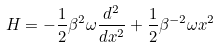<formula> <loc_0><loc_0><loc_500><loc_500>H = - \frac { 1 } { 2 } \beta ^ { 2 } \omega \frac { d ^ { 2 } } { d x ^ { 2 } } + \frac { 1 } { 2 } \beta ^ { - 2 } \omega x ^ { 2 }</formula> 